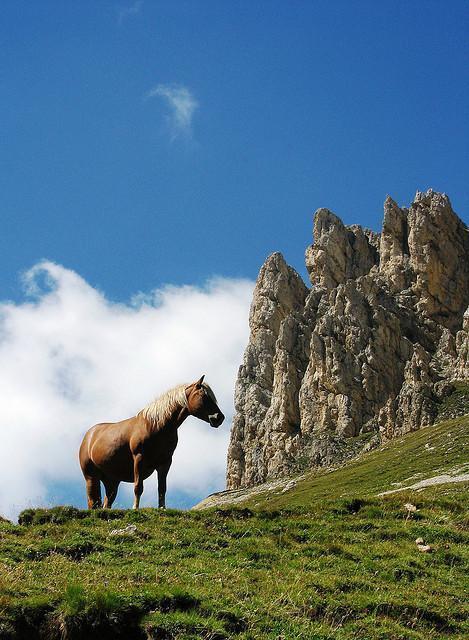How many zebras are visible?
Give a very brief answer. 0. 